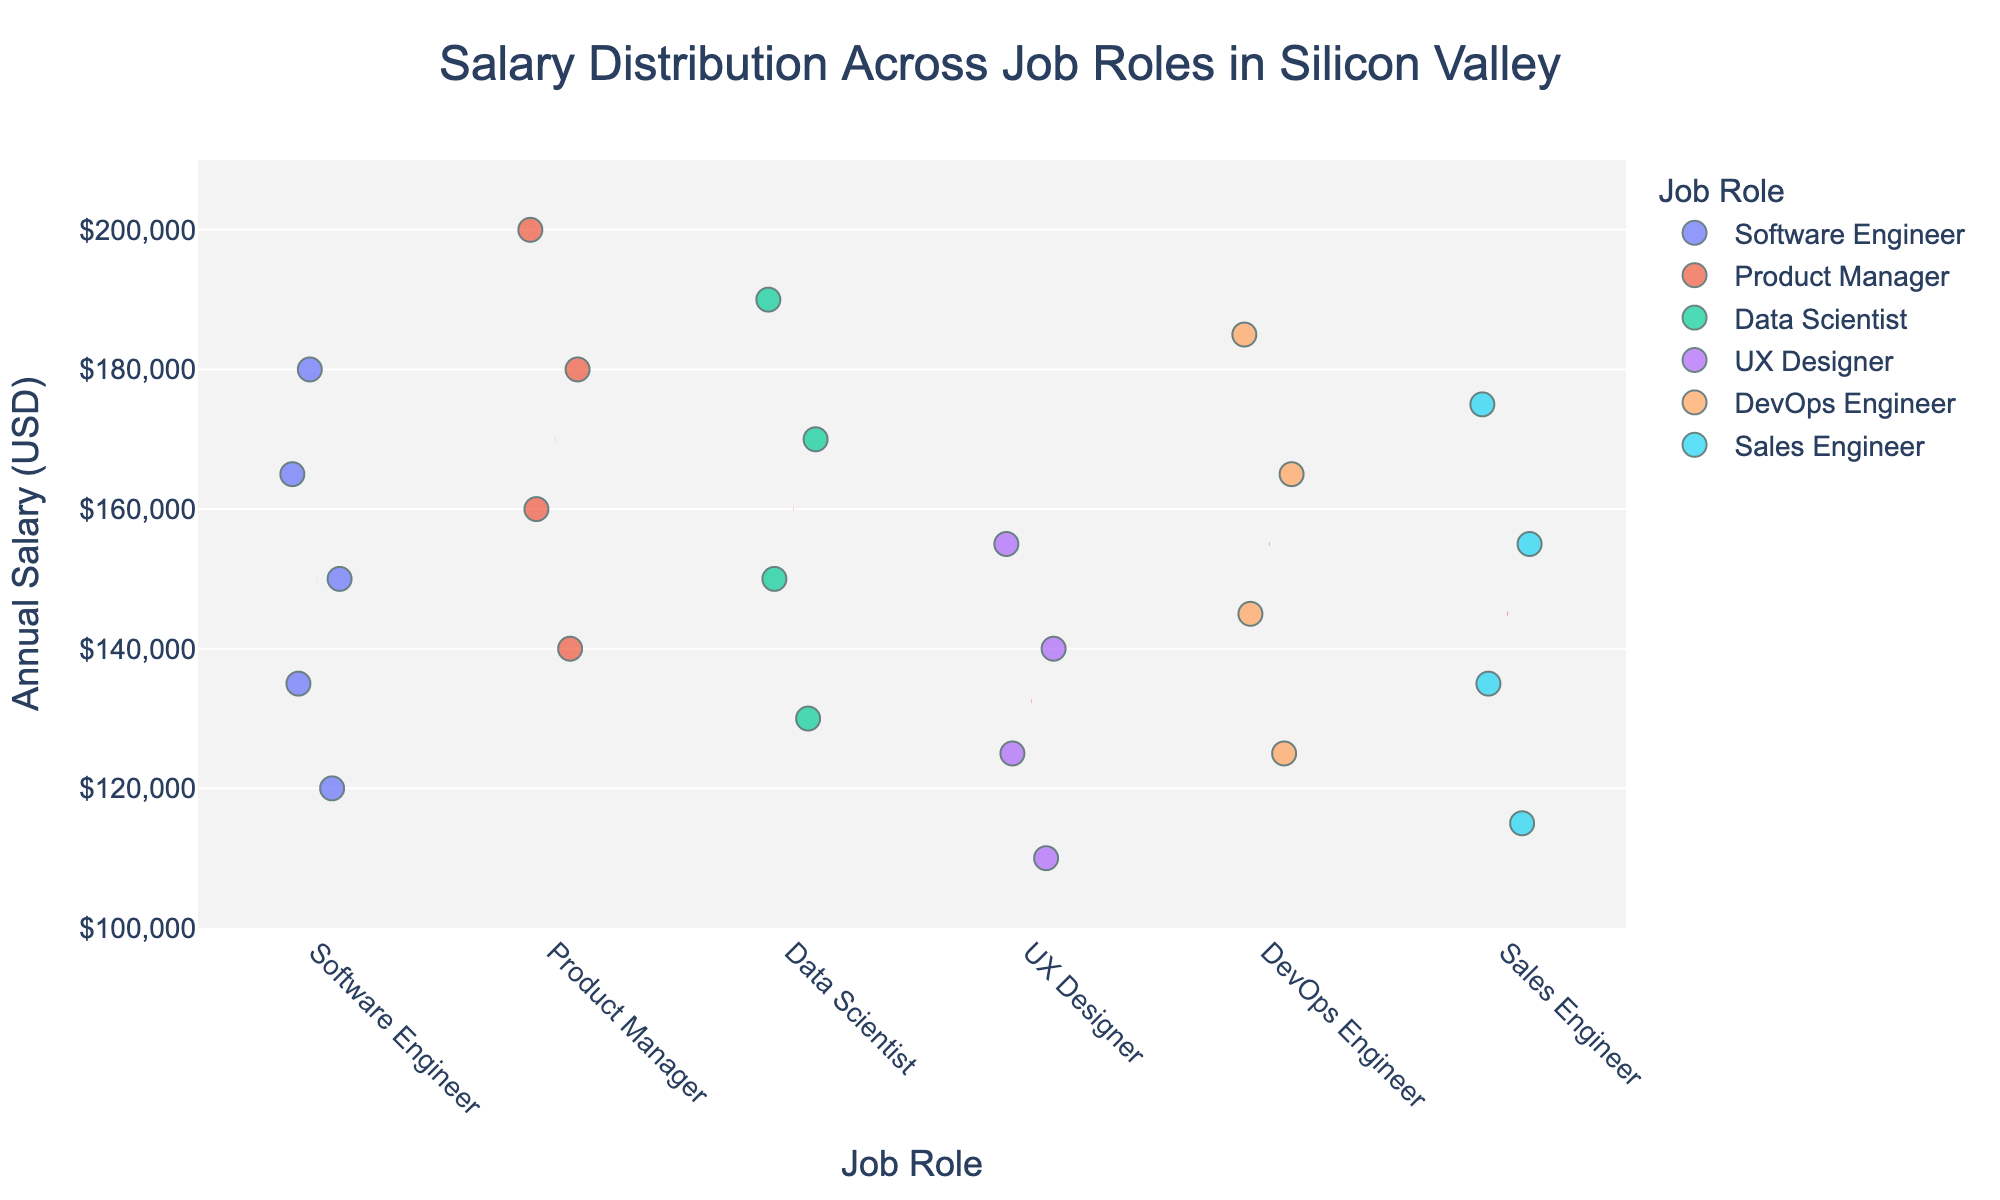What is the title of the plot? The title is prominently shown at the top of the plot.
Answer: Salary Distribution Across Job Roles in Silicon Valley What is the range of the y-axis? The y-axis range can be seen on the left side of the plot, which is marked from 100,000 to 210,000.
Answer: 100,000 to 210,000 Which job role has the highest listed salary? By looking at the top points of each job role's distribution, the highest salary belongs to the Product Manager role, hitting 200,000.
Answer: Product Manager What is the average salary for a Software Engineer? A red dashed line indicates the mean salary for each job role. Against the Software Engineer points, the mean line is around 157,500.
Answer: 157,500 How many job roles are represented in the plot? Count the distinct categories on the x-axis, which shows different job roles. There are six: Software Engineer, Product Manager, Data Scientist, UX Designer, DevOps Engineer, and Sales Engineer.
Answer: 6 Which job role has the lowest range of salaries? By observing the spread of the data points along the y-axis for each job role, UX Designer shows the narrowest range, from around 110,000 to 155,000.
Answer: UX Designer What is the mean salary for a Product Manager? The red dashed line across the Product Manager job role indicators shows the mean salary, which is around 170,000.
Answer: 170,000 Which job role has a higher average salary, Data Scientist or Sales Engineer? Comparing the red dashed mean lines for Data Scientist and Sales Engineer, Data Scientist has a higher average (around 160,000 compared to Sales Engineer’s 145,000).
Answer: Data Scientist How does the salary distribution for DevOps Engineers compare to that of Data Scientists? By comparing the spread and the mean lines of DevOps Engineers and Data Scientists, DevOps Engineers have a higher upper range but a similar spread, with both distributions centered around the 145,000 to 165,000 range.
Answer: Similar spread, higher upper range for DevOps Engineers What is the salary range for Sales Engineers? Observe the lowest and highest points in the Sales Engineer category, which range from 115,000 to 175,000.
Answer: 115,000 to 175,000 